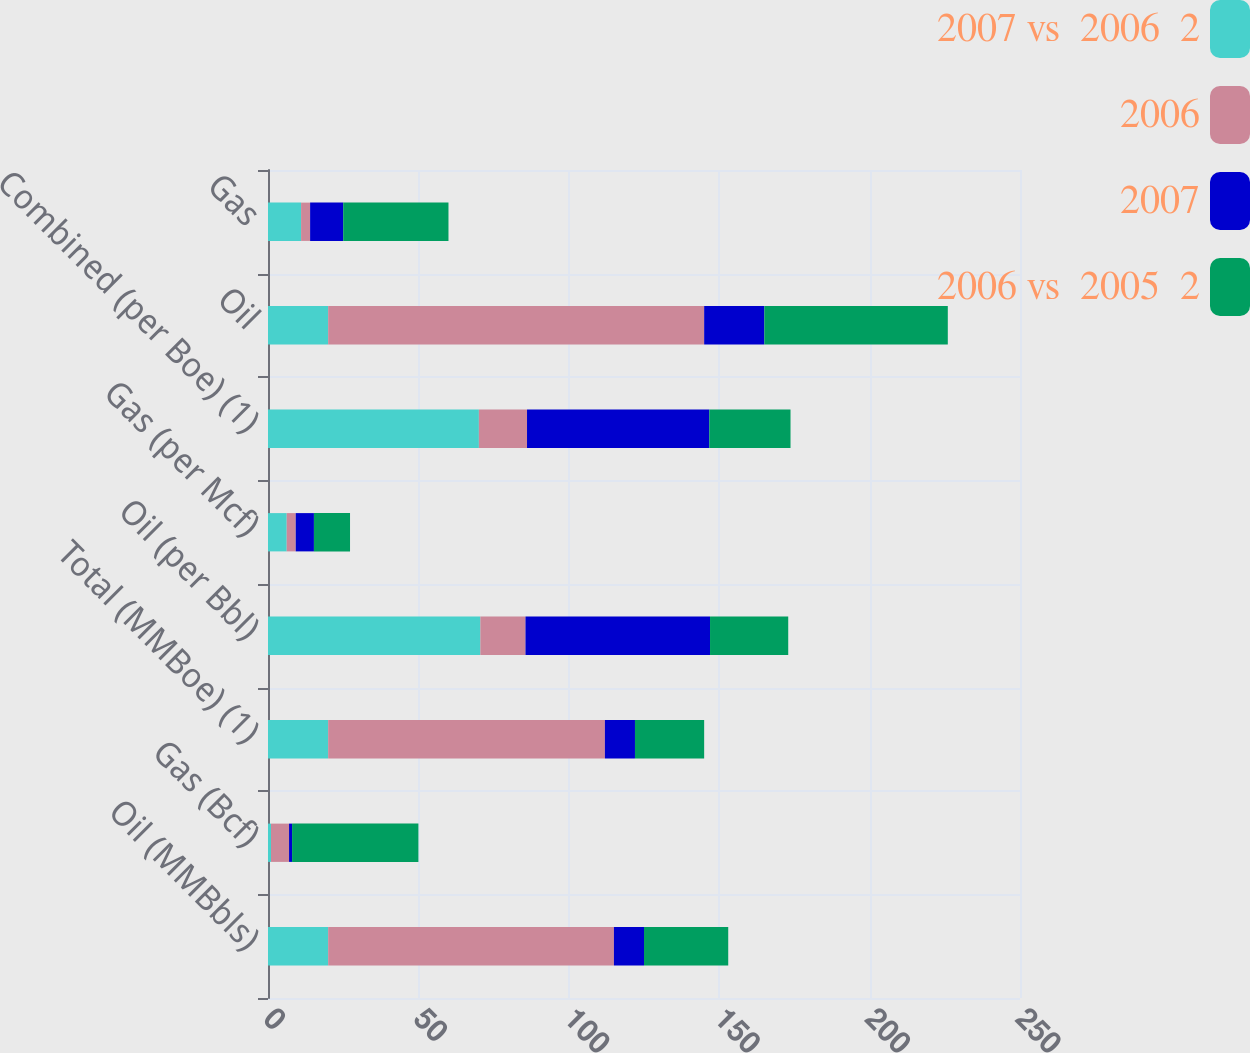Convert chart to OTSL. <chart><loc_0><loc_0><loc_500><loc_500><stacked_bar_chart><ecel><fcel>Oil (MMBbls)<fcel>Gas (Bcf)<fcel>Total (MMBoe) (1)<fcel>Oil (per Bbl)<fcel>Gas (per Mcf)<fcel>Combined (per Boe) (1)<fcel>Oil<fcel>Gas<nl><fcel>2007 vs  2006  2<fcel>20<fcel>1<fcel>20<fcel>70.6<fcel>6.22<fcel>70.11<fcel>20<fcel>11<nl><fcel>2006<fcel>95<fcel>6<fcel>92<fcel>15<fcel>3<fcel>16<fcel>125<fcel>3<nl><fcel>2007<fcel>10<fcel>1<fcel>10<fcel>61.35<fcel>6.05<fcel>60.6<fcel>20<fcel>11<nl><fcel>2006 vs  2005  2<fcel>28<fcel>42<fcel>23<fcel>26<fcel>12<fcel>27<fcel>61<fcel>35<nl></chart> 